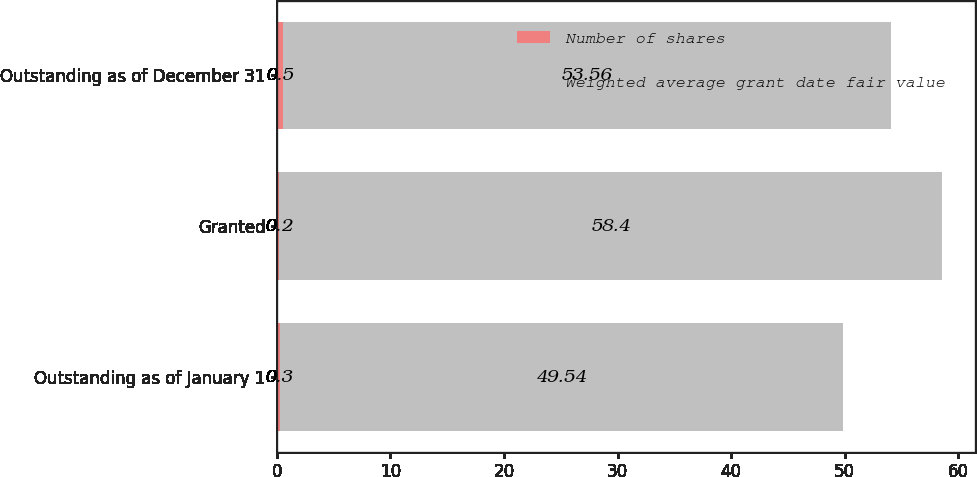Convert chart. <chart><loc_0><loc_0><loc_500><loc_500><stacked_bar_chart><ecel><fcel>Outstanding as of January 1<fcel>Granted<fcel>Outstanding as of December 31<nl><fcel>Number of shares<fcel>0.3<fcel>0.2<fcel>0.5<nl><fcel>Weighted average grant date fair value<fcel>49.54<fcel>58.4<fcel>53.56<nl></chart> 